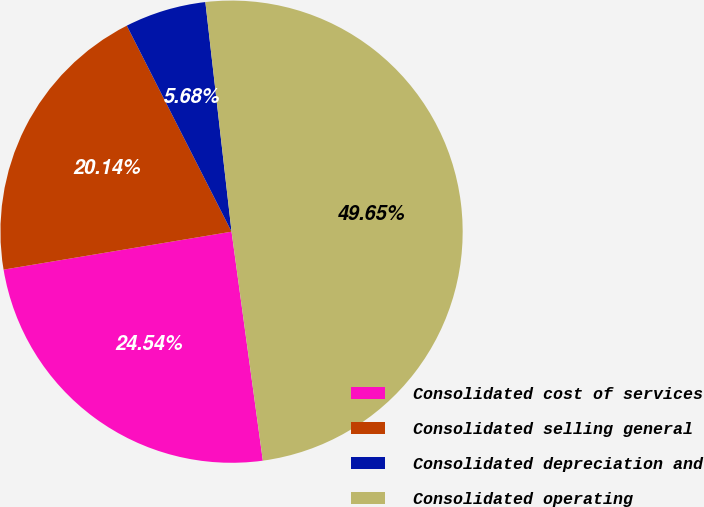Convert chart to OTSL. <chart><loc_0><loc_0><loc_500><loc_500><pie_chart><fcel>Consolidated cost of services<fcel>Consolidated selling general<fcel>Consolidated depreciation and<fcel>Consolidated operating<nl><fcel>24.54%<fcel>20.14%<fcel>5.68%<fcel>49.65%<nl></chart> 